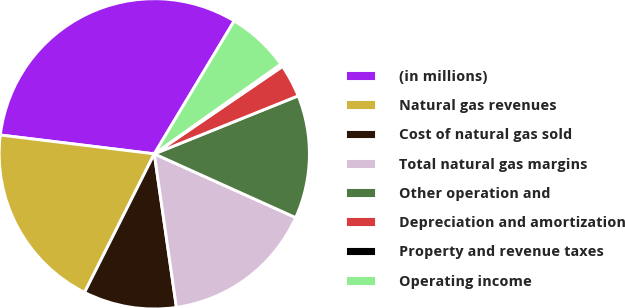Convert chart to OTSL. <chart><loc_0><loc_0><loc_500><loc_500><pie_chart><fcel>(in millions)<fcel>Natural gas revenues<fcel>Cost of natural gas sold<fcel>Total natural gas margins<fcel>Other operation and<fcel>Depreciation and amortization<fcel>Property and revenue taxes<fcel>Operating income<nl><fcel>31.68%<fcel>19.52%<fcel>9.7%<fcel>15.98%<fcel>12.84%<fcel>3.43%<fcel>0.29%<fcel>6.57%<nl></chart> 